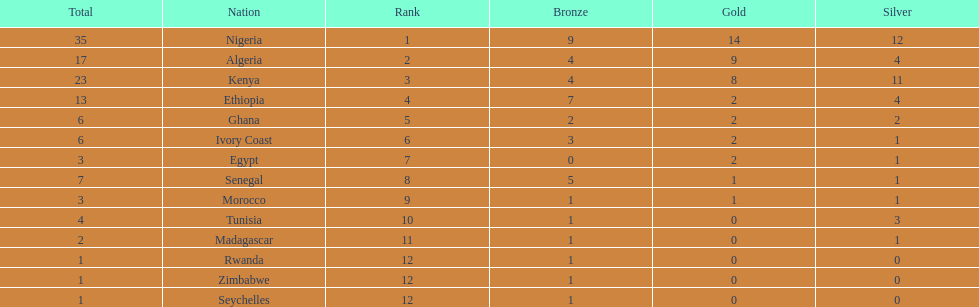How many silver medals did kenya earn? 11. 